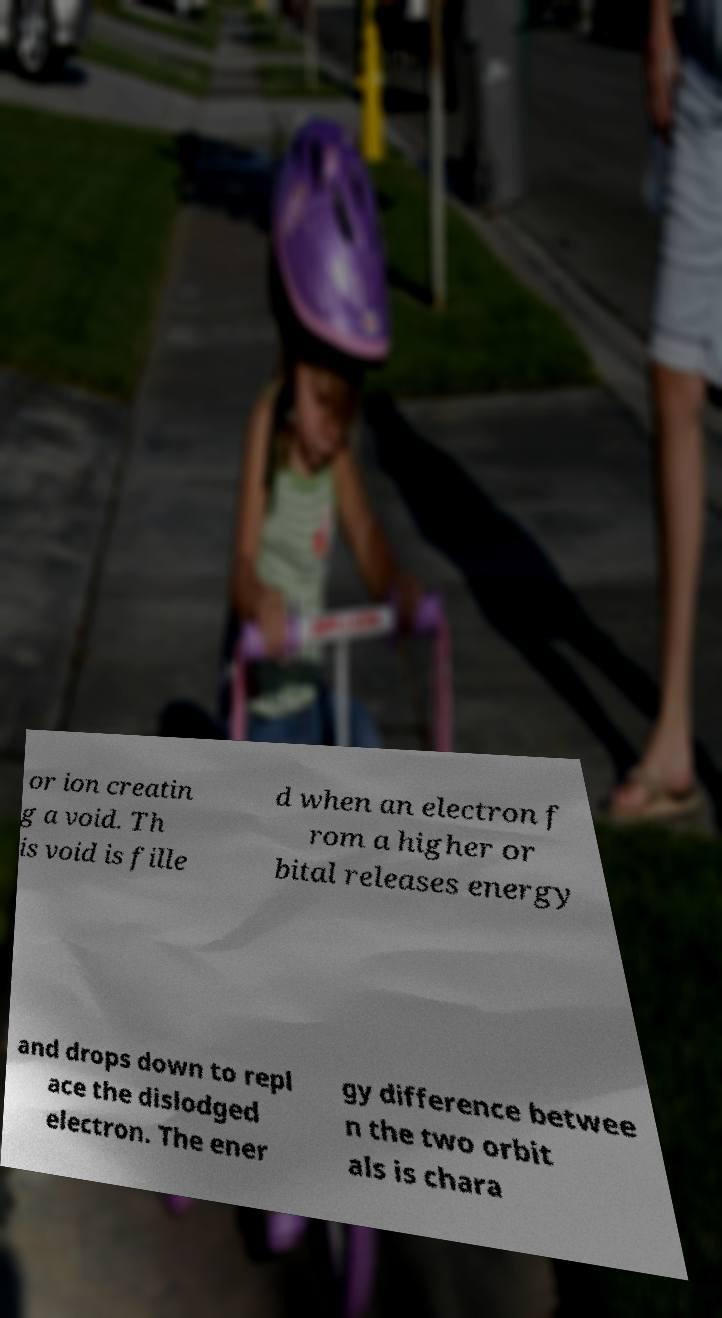Please identify and transcribe the text found in this image. or ion creatin g a void. Th is void is fille d when an electron f rom a higher or bital releases energy and drops down to repl ace the dislodged electron. The ener gy difference betwee n the two orbit als is chara 